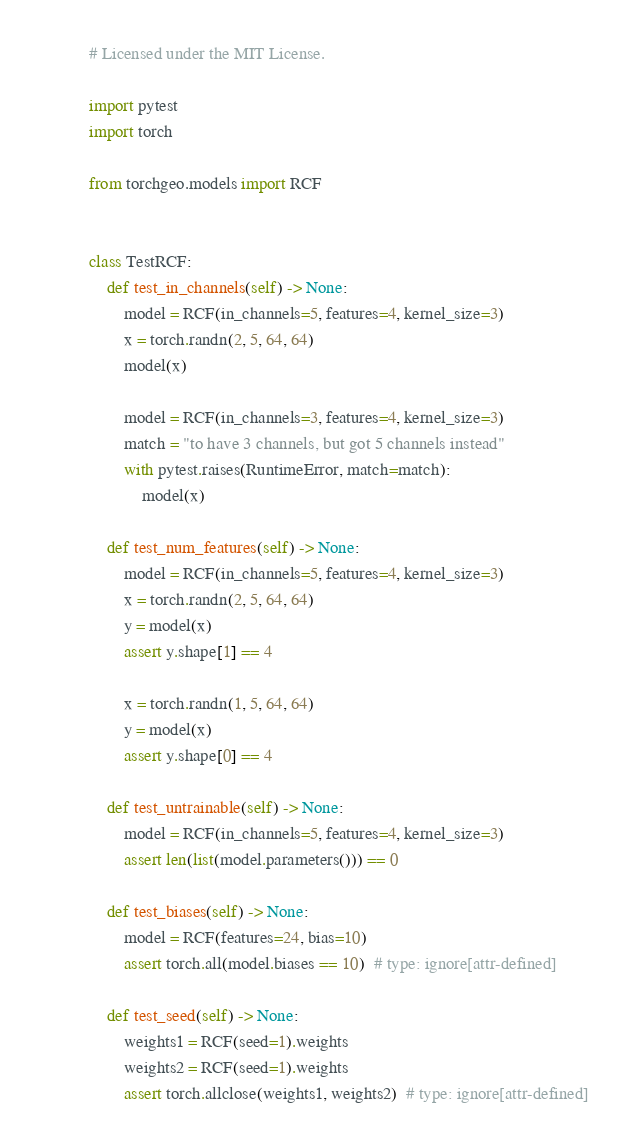Convert code to text. <code><loc_0><loc_0><loc_500><loc_500><_Python_># Licensed under the MIT License.

import pytest
import torch

from torchgeo.models import RCF


class TestRCF:
    def test_in_channels(self) -> None:
        model = RCF(in_channels=5, features=4, kernel_size=3)
        x = torch.randn(2, 5, 64, 64)
        model(x)

        model = RCF(in_channels=3, features=4, kernel_size=3)
        match = "to have 3 channels, but got 5 channels instead"
        with pytest.raises(RuntimeError, match=match):
            model(x)

    def test_num_features(self) -> None:
        model = RCF(in_channels=5, features=4, kernel_size=3)
        x = torch.randn(2, 5, 64, 64)
        y = model(x)
        assert y.shape[1] == 4

        x = torch.randn(1, 5, 64, 64)
        y = model(x)
        assert y.shape[0] == 4

    def test_untrainable(self) -> None:
        model = RCF(in_channels=5, features=4, kernel_size=3)
        assert len(list(model.parameters())) == 0

    def test_biases(self) -> None:
        model = RCF(features=24, bias=10)
        assert torch.all(model.biases == 10)  # type: ignore[attr-defined]

    def test_seed(self) -> None:
        weights1 = RCF(seed=1).weights
        weights2 = RCF(seed=1).weights
        assert torch.allclose(weights1, weights2)  # type: ignore[attr-defined]
</code> 